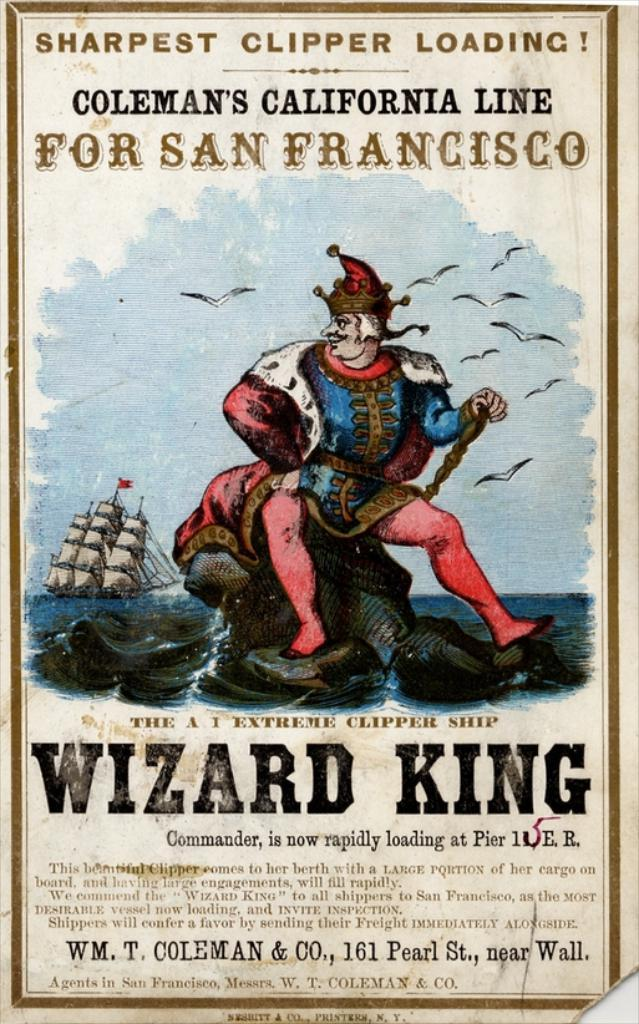<image>
Write a terse but informative summary of the picture. a poster with the wizard king on the front of it 